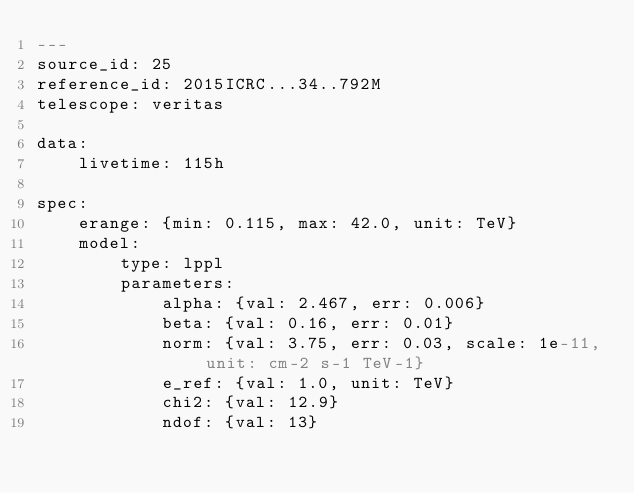<code> <loc_0><loc_0><loc_500><loc_500><_YAML_>---
source_id: 25
reference_id: 2015ICRC...34..792M
telescope: veritas

data:
    livetime: 115h

spec:
    erange: {min: 0.115, max: 42.0, unit: TeV}
    model:
        type: lppl
        parameters:
            alpha: {val: 2.467, err: 0.006}
            beta: {val: 0.16, err: 0.01}
            norm: {val: 3.75, err: 0.03, scale: 1e-11, unit: cm-2 s-1 TeV-1}
            e_ref: {val: 1.0, unit: TeV}
            chi2: {val: 12.9}
            ndof: {val: 13}
</code> 